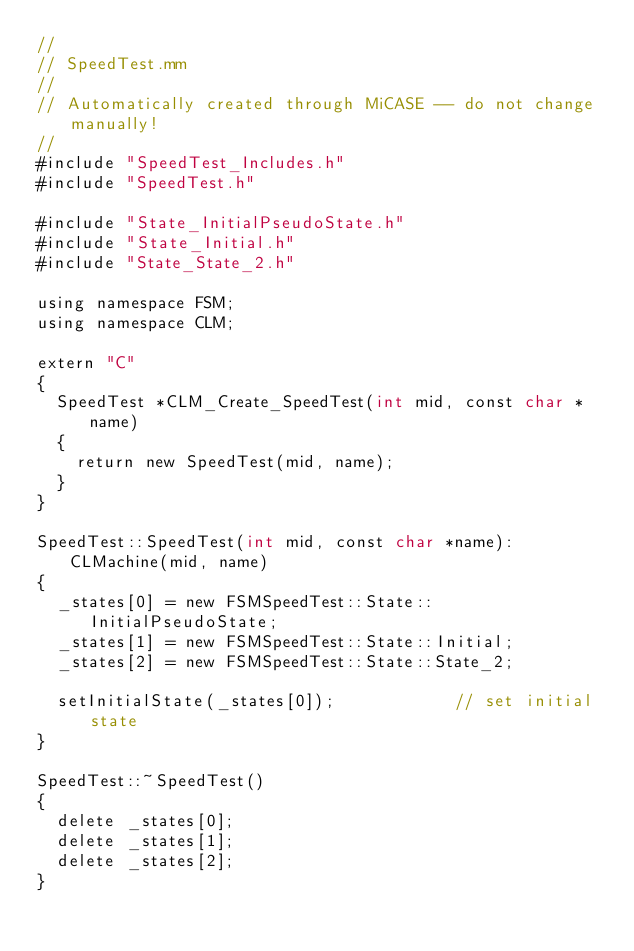Convert code to text. <code><loc_0><loc_0><loc_500><loc_500><_ObjectiveC_>//
// SpeedTest.mm
//
// Automatically created through MiCASE -- do not change manually!
//
#include "SpeedTest_Includes.h"
#include "SpeedTest.h"

#include "State_InitialPseudoState.h"
#include "State_Initial.h"
#include "State_State_2.h"

using namespace FSM;
using namespace CLM;

extern "C"
{
	SpeedTest *CLM_Create_SpeedTest(int mid, const char *name)
	{
		return new SpeedTest(mid, name);
	}
}

SpeedTest::SpeedTest(int mid, const char *name): CLMachine(mid, name)
{
	_states[0] = new FSMSpeedTest::State::InitialPseudoState;
	_states[1] = new FSMSpeedTest::State::Initial;
	_states[2] = new FSMSpeedTest::State::State_2;

	setInitialState(_states[0]);            // set initial state
}

SpeedTest::~SpeedTest()
{
	delete _states[0];
	delete _states[1];
	delete _states[2];
}
</code> 